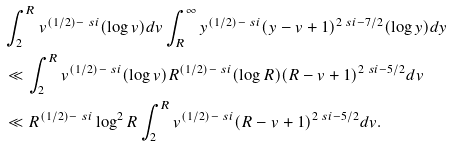<formula> <loc_0><loc_0><loc_500><loc_500>& \int _ { 2 } ^ { R } v ^ { ( 1 / 2 ) - \ s i } ( \log v ) d v \int _ { R } ^ { \infty } y ^ { ( 1 / 2 ) - \ s i } ( y - v + 1 ) ^ { 2 \ s i - 7 / 2 } ( \log y ) d y \\ & \ll \int _ { 2 } ^ { R } v ^ { ( 1 / 2 ) - \ s i } ( \log v ) R ^ { ( 1 / 2 ) - \ s i } ( \log R ) ( R - v + 1 ) ^ { 2 \ s i - 5 / 2 } d v \\ & \ll R ^ { ( 1 / 2 ) - \ s i } \log ^ { 2 } R \int _ { 2 } ^ { R } v ^ { ( 1 / 2 ) - \ s i } ( R - v + 1 ) ^ { 2 \ s i - 5 / 2 } d v .</formula> 